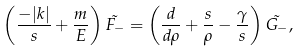<formula> <loc_0><loc_0><loc_500><loc_500>\left ( \frac { - | k | } { s } + \frac { m } { E } \right ) \tilde { F _ { - } } = \left ( \frac { d } { d \rho } + \frac { s } { \rho } - \frac { \gamma } { s } \right ) \tilde { G _ { - } } ,</formula> 